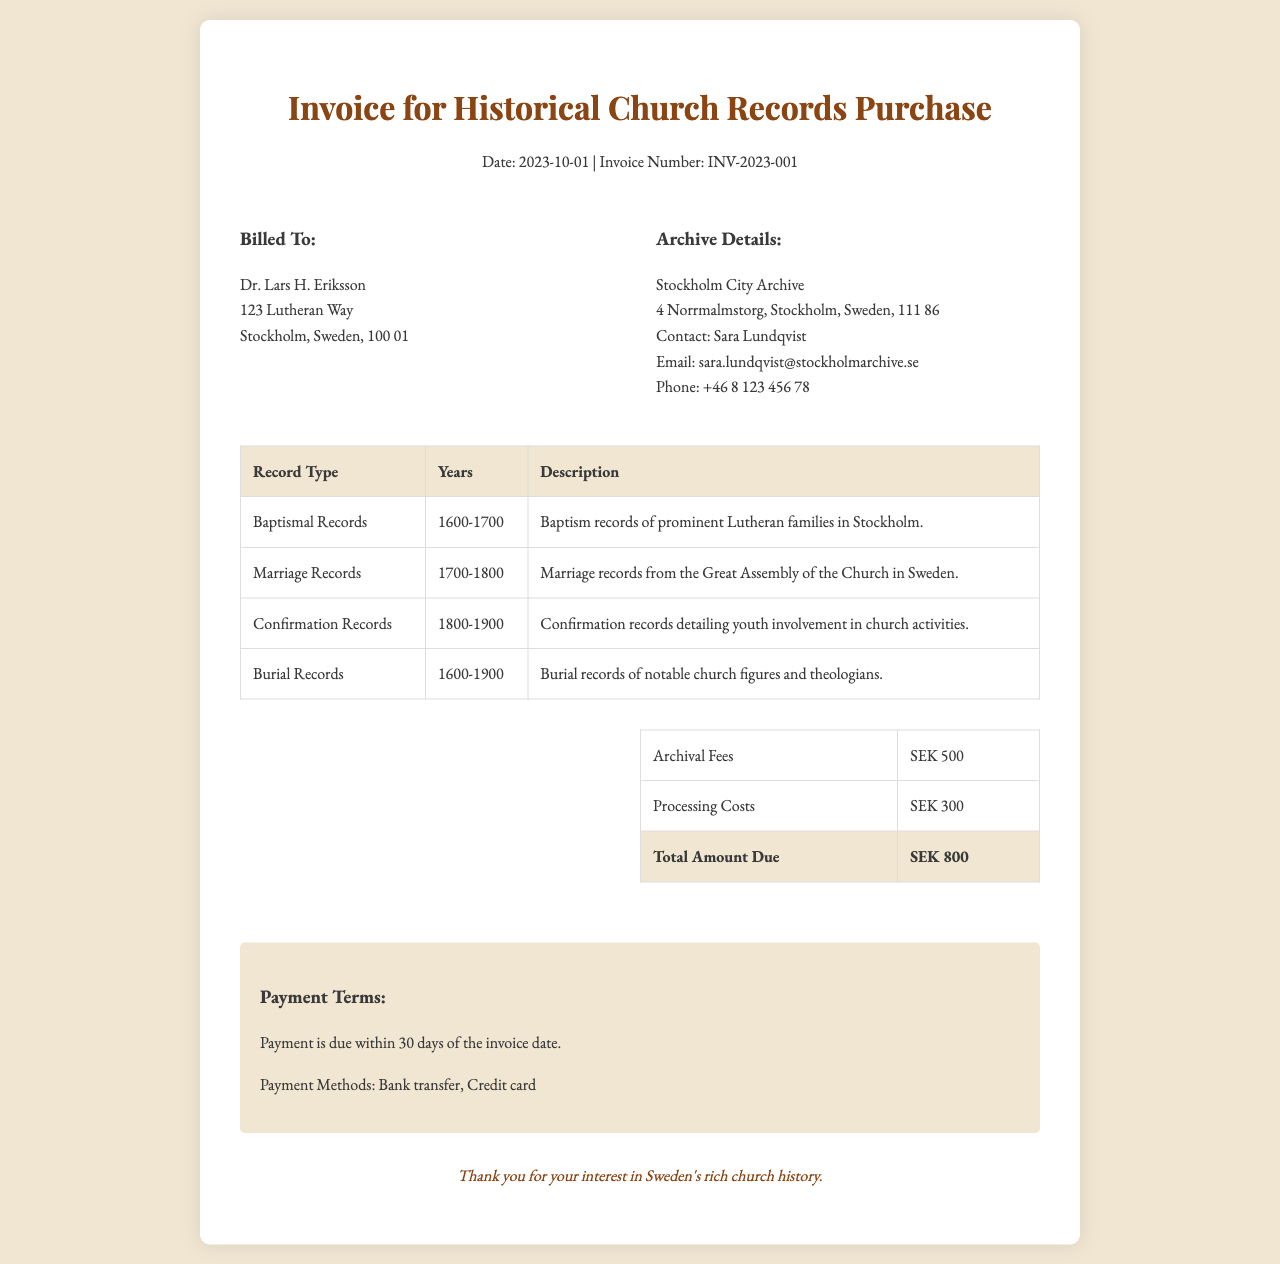What is the date of the invoice? The invoice date is mentioned at the top of the document near the title.
Answer: 2023-10-01 What is the total amount due? The total amount due is calculated from the archival fees and processing costs listed in the costs table.
Answer: SEK 800 Who is billed in this invoice? The invoice has a section identifying the billed individual.
Answer: Dr. Lars H. Eriksson What type of records are included for the years 1800-1900? This refers to a specific record type and its corresponding years listed in the records table.
Answer: Confirmation Records What is the archival fee listed in the document? The costs table specifies different fees, and one of them is labeled as archival fees.
Answer: SEK 500 How can payment be made? The payment methods are specified in a dedicated section towards the end of the document.
Answer: Bank transfer, Credit card What is the purpose of this invoice? The title at the top of the document directly indicates the reason for the invoice.
Answer: Historical Church Records Purchase Who can be contacted at the archive? The archive details section provides contact information for the individual responsible at the archive.
Answer: Sara Lundqvist What is the processing cost listed in the document? The costs table displays various charges, one of which is for processing.
Answer: SEK 300 